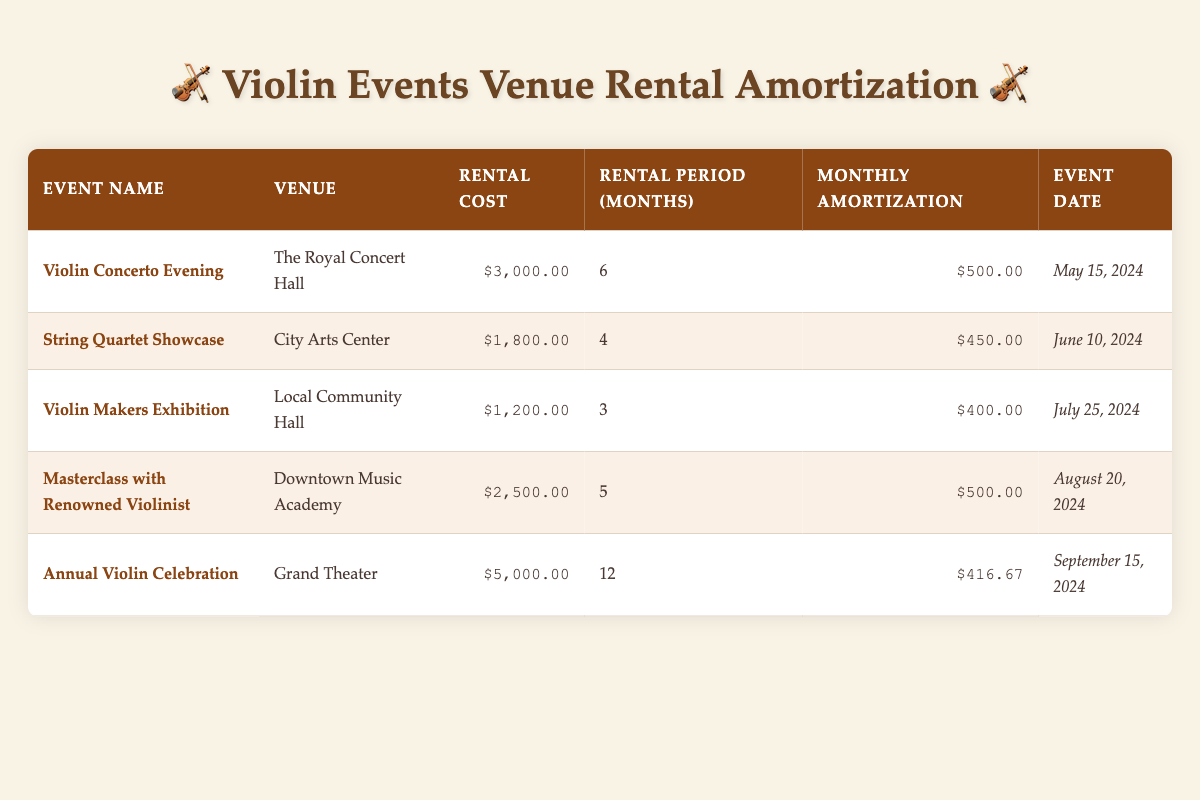What is the rental cost for the "Violin Concerto Evening"? The table lists the rental cost for each event. For the "Violin Concerto Evening," the rental cost is specified as $3,000.00.
Answer: $3,000.00 How much is the monthly amortization for the "Annual Violin Celebration"? In the table, the monthly amortization for the "Annual Violin Celebration" is indicated as $416.67.
Answer: $416.67 Which venue has the highest rental cost? By examining the rental costs in the table, the "Annual Violin Celebration" at the Grand Theater has the highest rental cost of $5,000.00.
Answer: Grand Theater What is the total rental cost for all events listed? To find the total, I will sum the rental costs: $3,000.00 + $1,800.00 + $1,200.00 + $2,500.00 + $5,000.00 = $13,500.00.
Answer: $13,500.00 Is the "Masterclass with Renowned Violinist" scheduled before the "String Quartet Showcase"? The event dates show that "Masterclass with Renowned Violinist" is on August 20, 2024, while "String Quartet Showcase" is on June 10, 2024. Since August is after June, the statement is false.
Answer: No What is the average monthly amortization across all events? To find the average, I add the monthly amortizations: $500.00 + $450.00 + $400.00 + $500.00 + $416.67 = $2266.67. There are 5 events, so the average is $2266.67 / 5 = $453.33.
Answer: $453.33 Which event has the shortest rental period? By reviewing the rental periods listed, the "Violin Makers Exhibition" has the shortest rental period of 3 months.
Answer: Violin Makers Exhibition Are there any events taking place in July? The table lists the event dates, and "Violin Makers Exhibition" is scheduled for July 25, 2024. Therefore, there is indeed an event in July.
Answer: Yes What is the rental cost difference between the "Violin Concerto Evening" and the "String Quartet Showcase"? To find the difference, I will subtract the rental cost of the "String Quartet Showcase" ($1,800.00) from the "Violin Concerto Evening" ($3,000.00). The difference is $3,000.00 - $1,800.00 = $1,200.00.
Answer: $1,200.00 